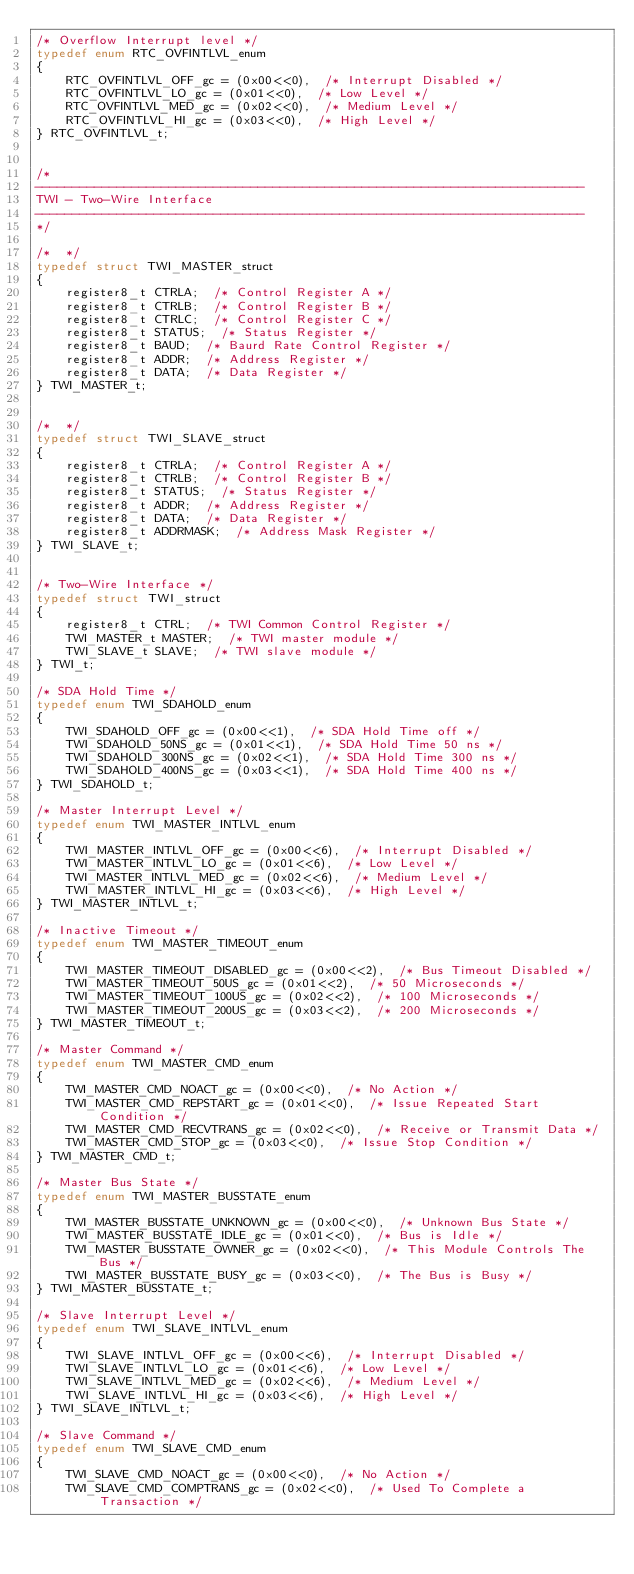<code> <loc_0><loc_0><loc_500><loc_500><_C_>/* Overflow Interrupt level */
typedef enum RTC_OVFINTLVL_enum
{
    RTC_OVFINTLVL_OFF_gc = (0x00<<0),  /* Interrupt Disabled */
    RTC_OVFINTLVL_LO_gc = (0x01<<0),  /* Low Level */
    RTC_OVFINTLVL_MED_gc = (0x02<<0),  /* Medium Level */
    RTC_OVFINTLVL_HI_gc = (0x03<<0),  /* High Level */
} RTC_OVFINTLVL_t;


/*
--------------------------------------------------------------------------
TWI - Two-Wire Interface
--------------------------------------------------------------------------
*/

/*  */
typedef struct TWI_MASTER_struct
{
    register8_t CTRLA;  /* Control Register A */
    register8_t CTRLB;  /* Control Register B */
    register8_t CTRLC;  /* Control Register C */
    register8_t STATUS;  /* Status Register */
    register8_t BAUD;  /* Baurd Rate Control Register */
    register8_t ADDR;  /* Address Register */
    register8_t DATA;  /* Data Register */
} TWI_MASTER_t;


/*  */
typedef struct TWI_SLAVE_struct
{
    register8_t CTRLA;  /* Control Register A */
    register8_t CTRLB;  /* Control Register B */
    register8_t STATUS;  /* Status Register */
    register8_t ADDR;  /* Address Register */
    register8_t DATA;  /* Data Register */
    register8_t ADDRMASK;  /* Address Mask Register */
} TWI_SLAVE_t;


/* Two-Wire Interface */
typedef struct TWI_struct
{
    register8_t CTRL;  /* TWI Common Control Register */
    TWI_MASTER_t MASTER;  /* TWI master module */
    TWI_SLAVE_t SLAVE;  /* TWI slave module */
} TWI_t;

/* SDA Hold Time */
typedef enum TWI_SDAHOLD_enum
{
    TWI_SDAHOLD_OFF_gc = (0x00<<1),  /* SDA Hold Time off */
    TWI_SDAHOLD_50NS_gc = (0x01<<1),  /* SDA Hold Time 50 ns */
    TWI_SDAHOLD_300NS_gc = (0x02<<1),  /* SDA Hold Time 300 ns */
    TWI_SDAHOLD_400NS_gc = (0x03<<1),  /* SDA Hold Time 400 ns */
} TWI_SDAHOLD_t;

/* Master Interrupt Level */
typedef enum TWI_MASTER_INTLVL_enum
{
    TWI_MASTER_INTLVL_OFF_gc = (0x00<<6),  /* Interrupt Disabled */
    TWI_MASTER_INTLVL_LO_gc = (0x01<<6),  /* Low Level */
    TWI_MASTER_INTLVL_MED_gc = (0x02<<6),  /* Medium Level */
    TWI_MASTER_INTLVL_HI_gc = (0x03<<6),  /* High Level */
} TWI_MASTER_INTLVL_t;

/* Inactive Timeout */
typedef enum TWI_MASTER_TIMEOUT_enum
{
    TWI_MASTER_TIMEOUT_DISABLED_gc = (0x00<<2),  /* Bus Timeout Disabled */
    TWI_MASTER_TIMEOUT_50US_gc = (0x01<<2),  /* 50 Microseconds */
    TWI_MASTER_TIMEOUT_100US_gc = (0x02<<2),  /* 100 Microseconds */
    TWI_MASTER_TIMEOUT_200US_gc = (0x03<<2),  /* 200 Microseconds */
} TWI_MASTER_TIMEOUT_t;

/* Master Command */
typedef enum TWI_MASTER_CMD_enum
{
    TWI_MASTER_CMD_NOACT_gc = (0x00<<0),  /* No Action */
    TWI_MASTER_CMD_REPSTART_gc = (0x01<<0),  /* Issue Repeated Start Condition */
    TWI_MASTER_CMD_RECVTRANS_gc = (0x02<<0),  /* Receive or Transmit Data */
    TWI_MASTER_CMD_STOP_gc = (0x03<<0),  /* Issue Stop Condition */
} TWI_MASTER_CMD_t;

/* Master Bus State */
typedef enum TWI_MASTER_BUSSTATE_enum
{
    TWI_MASTER_BUSSTATE_UNKNOWN_gc = (0x00<<0),  /* Unknown Bus State */
    TWI_MASTER_BUSSTATE_IDLE_gc = (0x01<<0),  /* Bus is Idle */
    TWI_MASTER_BUSSTATE_OWNER_gc = (0x02<<0),  /* This Module Controls The Bus */
    TWI_MASTER_BUSSTATE_BUSY_gc = (0x03<<0),  /* The Bus is Busy */
} TWI_MASTER_BUSSTATE_t;

/* Slave Interrupt Level */
typedef enum TWI_SLAVE_INTLVL_enum
{
    TWI_SLAVE_INTLVL_OFF_gc = (0x00<<6),  /* Interrupt Disabled */
    TWI_SLAVE_INTLVL_LO_gc = (0x01<<6),  /* Low Level */
    TWI_SLAVE_INTLVL_MED_gc = (0x02<<6),  /* Medium Level */
    TWI_SLAVE_INTLVL_HI_gc = (0x03<<6),  /* High Level */
} TWI_SLAVE_INTLVL_t;

/* Slave Command */
typedef enum TWI_SLAVE_CMD_enum
{
    TWI_SLAVE_CMD_NOACT_gc = (0x00<<0),  /* No Action */
    TWI_SLAVE_CMD_COMPTRANS_gc = (0x02<<0),  /* Used To Complete a Transaction */</code> 